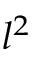<formula> <loc_0><loc_0><loc_500><loc_500>l ^ { 2 }</formula> 